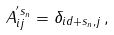<formula> <loc_0><loc_0><loc_500><loc_500>A ^ { ^ { \prime } s _ { n } } _ { i j } = \delta _ { i d + s _ { n } , j } \, ,</formula> 